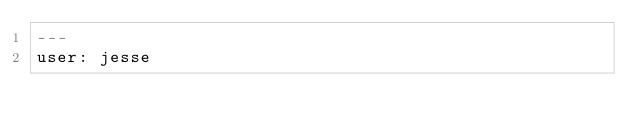<code> <loc_0><loc_0><loc_500><loc_500><_YAML_>---
user: jesse
</code> 